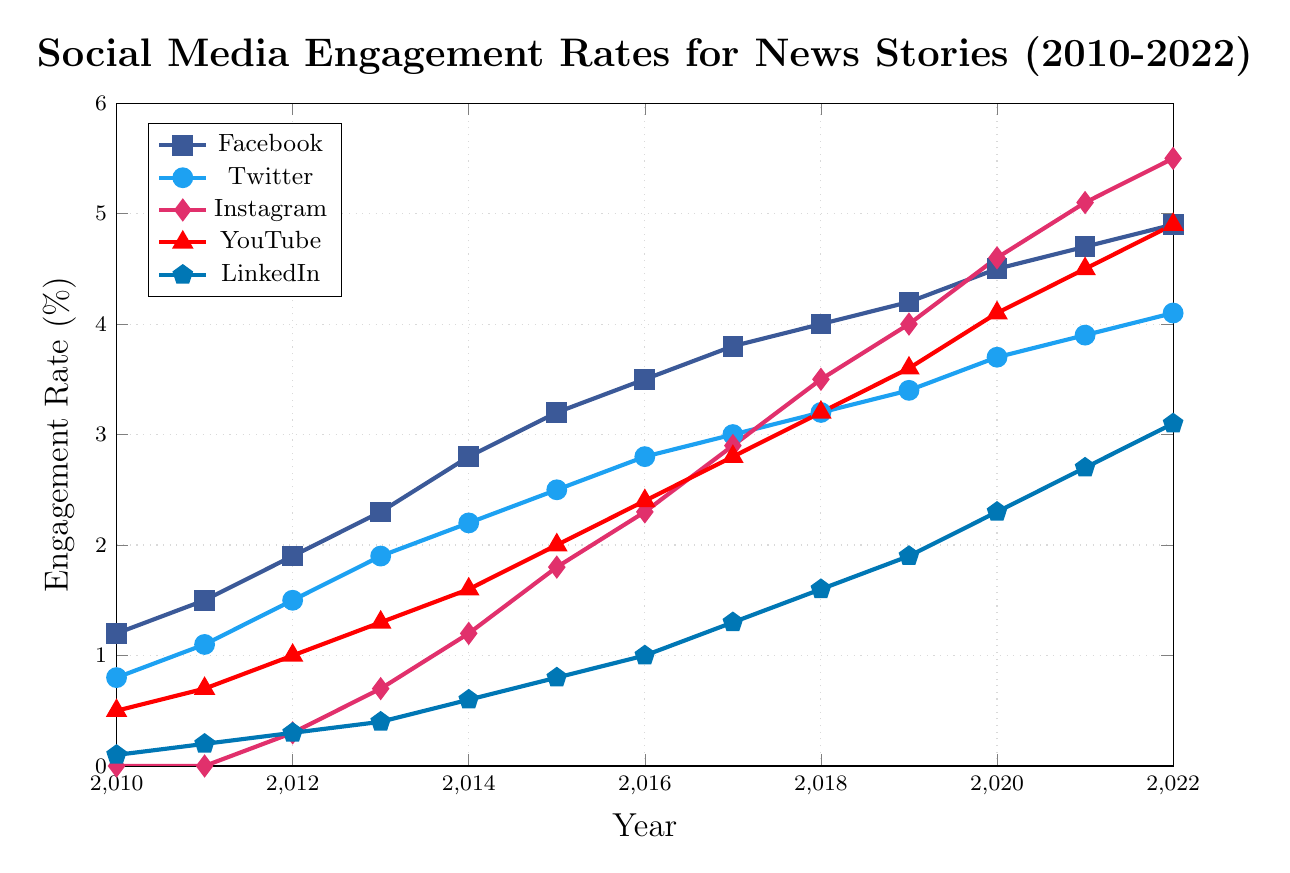Which social media platform had the highest engagement rate in 2022? Reviewing the plot, Instagram has the highest engagement rate in 2022, represented at 5.5% on the visual scale.
Answer: Instagram How did the engagement rate for LinkedIn change from 2010 to 2022? From the visual data, LinkedIn's engagement rate increased from 0.1% in 2010 to 3.1% in 2022.
Answer: It increased Which year showed the greatest increase in Instagram engagement rate compared to the previous year? By analyzing the plot, the greatest increase in Instagram engagement rate occured between 2014 (1.2%) and 2015 (1.8%), a rise of 0.6%.
Answer: 2015 Between 2010 and 2022, which platform showed the smallest overall increase in engagement? Observing the plot, Facebook's engagement rate increased from 1.2% to 4.9%, Twitter's from 0.8% to 4.1%, Instagram's from 0.0% to 5.5%, YouTube's from 0.5% to 4.9%, and LinkedIn's from 0.1% to 3.1%. LinkedIn showed the smallest increase overall.
Answer: LinkedIn In 2016, how did the engagement rates for YouTube and Instagram compare? The plot indicates that in 2016, YouTube had an engagement rate of 2.4%, while Instagram's rate was 2.3%.
Answer: YouTube was higher Which platform showed a consistent increase in engagement rates every year from 2010 to 2022? Reviewing the plot, both Facebook and Instagram show a consistent yearly increase in engagement rates throughout the period.
Answer: Facebook and Instagram What was the total engagement rate for all platforms combined in 2015? Summing the values for 2015, (Facebook: 3.2%) + (Twitter: 2.5%) + (Instagram: 1.8%) + (YouTube: 2.0%) + (LinkedIn: 0.8%) equals 10.3%.
Answer: 10.3% What is the average engagement rate for YouTube over the 13 years? Summing the yearly data points for YouTube and dividing by the number of years (2010-2022), (0.5 + 0.7 + 1.0 + 1.3 + 1.6 + 2.0 + 2.4 + 2.8 + 3.2 + 3.6 + 4.1 + 4.5 + 4.9) / 13 = 2.59%.
Answer: 2.59% Across all years, which platform had the lowest rate in any given year? Referring to the plot, Instagram had a rate of 0.0% in both 2010 and 2011—lower than any other platform’s lowest rate.
Answer: Instagram at 0.0% 